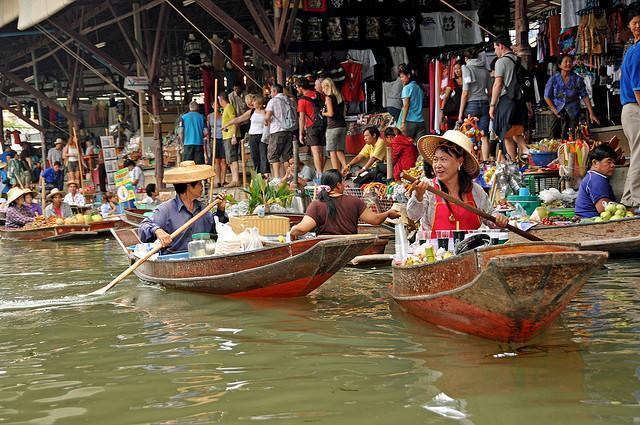How many boats are in the picture?
Give a very brief answer. 3. How many people can be seen?
Give a very brief answer. 6. 